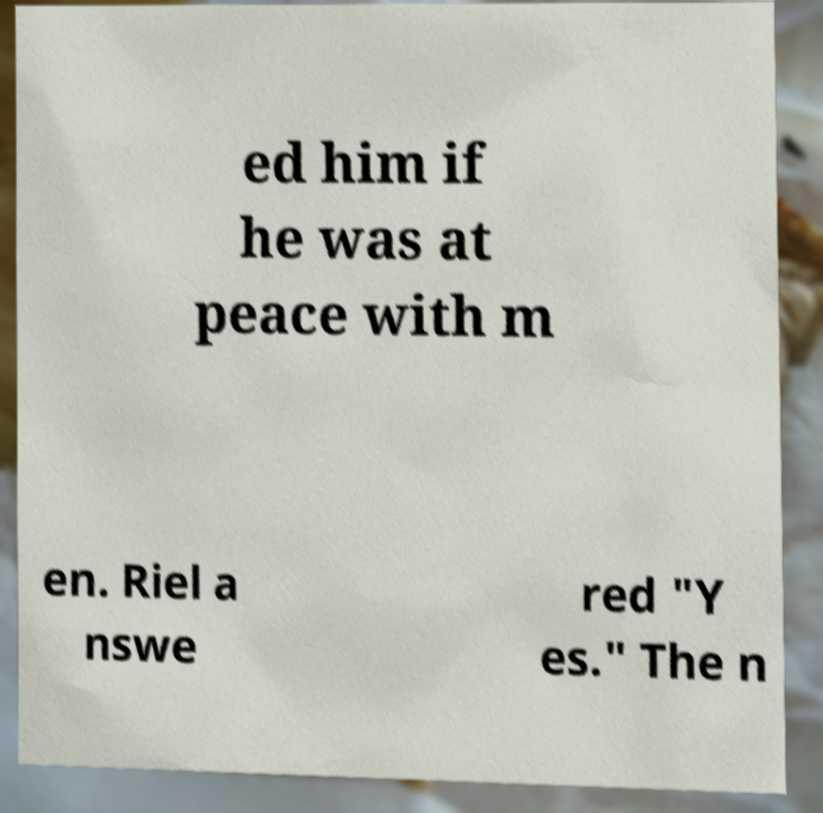Could you assist in decoding the text presented in this image and type it out clearly? ed him if he was at peace with m en. Riel a nswe red "Y es." The n 